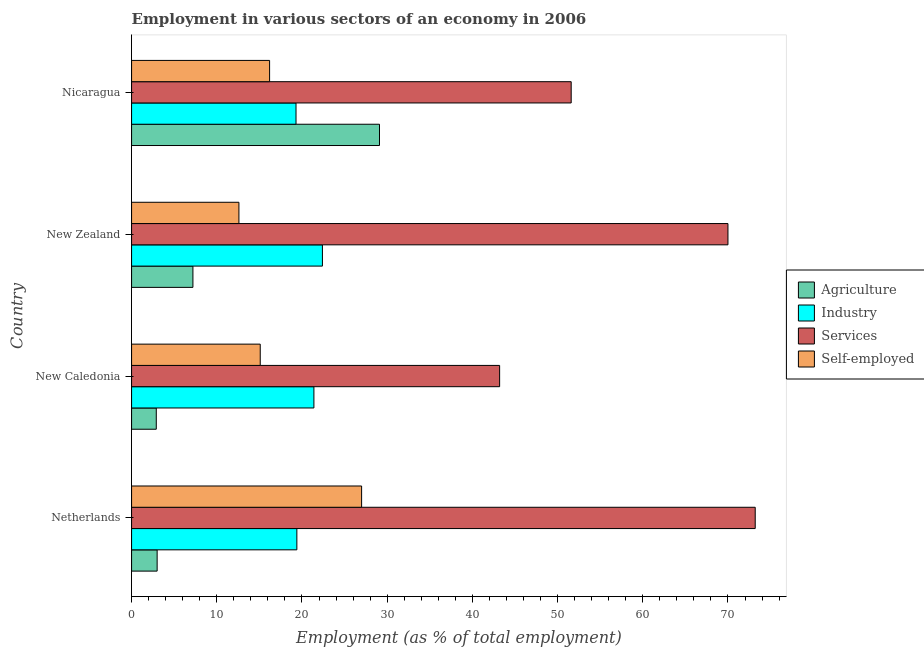Are the number of bars per tick equal to the number of legend labels?
Offer a very short reply. Yes. How many bars are there on the 2nd tick from the bottom?
Your answer should be compact. 4. What is the label of the 1st group of bars from the top?
Keep it short and to the point. Nicaragua. What is the percentage of workers in industry in Netherlands?
Your answer should be compact. 19.4. Across all countries, what is the maximum percentage of workers in agriculture?
Provide a succinct answer. 29.1. Across all countries, what is the minimum percentage of workers in services?
Provide a succinct answer. 43.2. In which country was the percentage of workers in industry maximum?
Keep it short and to the point. New Zealand. In which country was the percentage of workers in services minimum?
Keep it short and to the point. New Caledonia. What is the total percentage of workers in industry in the graph?
Offer a very short reply. 82.5. What is the difference between the percentage of workers in industry in Netherlands and that in New Caledonia?
Give a very brief answer. -2. What is the difference between the percentage of workers in agriculture in New Zealand and the percentage of workers in services in Nicaragua?
Provide a short and direct response. -44.4. What is the average percentage of workers in agriculture per country?
Give a very brief answer. 10.55. What is the difference between the percentage of workers in agriculture and percentage of workers in industry in Nicaragua?
Your answer should be very brief. 9.8. What is the ratio of the percentage of workers in agriculture in New Zealand to that in Nicaragua?
Make the answer very short. 0.25. What is the difference between the highest and the second highest percentage of workers in agriculture?
Your answer should be compact. 21.9. What does the 1st bar from the top in New Zealand represents?
Your answer should be compact. Self-employed. What does the 2nd bar from the bottom in New Zealand represents?
Offer a very short reply. Industry. Is it the case that in every country, the sum of the percentage of workers in agriculture and percentage of workers in industry is greater than the percentage of workers in services?
Keep it short and to the point. No. How many bars are there?
Offer a very short reply. 16. Are all the bars in the graph horizontal?
Your answer should be very brief. Yes. Are the values on the major ticks of X-axis written in scientific E-notation?
Offer a terse response. No. Where does the legend appear in the graph?
Your response must be concise. Center right. How many legend labels are there?
Keep it short and to the point. 4. How are the legend labels stacked?
Provide a succinct answer. Vertical. What is the title of the graph?
Offer a terse response. Employment in various sectors of an economy in 2006. Does "UNHCR" appear as one of the legend labels in the graph?
Keep it short and to the point. No. What is the label or title of the X-axis?
Your response must be concise. Employment (as % of total employment). What is the label or title of the Y-axis?
Your answer should be compact. Country. What is the Employment (as % of total employment) of Agriculture in Netherlands?
Provide a succinct answer. 3. What is the Employment (as % of total employment) of Industry in Netherlands?
Provide a short and direct response. 19.4. What is the Employment (as % of total employment) of Services in Netherlands?
Your answer should be compact. 73.2. What is the Employment (as % of total employment) in Agriculture in New Caledonia?
Keep it short and to the point. 2.9. What is the Employment (as % of total employment) of Industry in New Caledonia?
Your answer should be compact. 21.4. What is the Employment (as % of total employment) of Services in New Caledonia?
Your response must be concise. 43.2. What is the Employment (as % of total employment) in Self-employed in New Caledonia?
Your answer should be very brief. 15.1. What is the Employment (as % of total employment) of Agriculture in New Zealand?
Provide a succinct answer. 7.2. What is the Employment (as % of total employment) of Industry in New Zealand?
Ensure brevity in your answer.  22.4. What is the Employment (as % of total employment) of Services in New Zealand?
Your answer should be very brief. 70. What is the Employment (as % of total employment) of Self-employed in New Zealand?
Give a very brief answer. 12.6. What is the Employment (as % of total employment) of Agriculture in Nicaragua?
Your answer should be very brief. 29.1. What is the Employment (as % of total employment) in Industry in Nicaragua?
Give a very brief answer. 19.3. What is the Employment (as % of total employment) of Services in Nicaragua?
Provide a short and direct response. 51.6. What is the Employment (as % of total employment) of Self-employed in Nicaragua?
Provide a short and direct response. 16.2. Across all countries, what is the maximum Employment (as % of total employment) of Agriculture?
Your answer should be very brief. 29.1. Across all countries, what is the maximum Employment (as % of total employment) in Industry?
Give a very brief answer. 22.4. Across all countries, what is the maximum Employment (as % of total employment) in Services?
Offer a very short reply. 73.2. Across all countries, what is the maximum Employment (as % of total employment) of Self-employed?
Your answer should be very brief. 27. Across all countries, what is the minimum Employment (as % of total employment) in Agriculture?
Offer a very short reply. 2.9. Across all countries, what is the minimum Employment (as % of total employment) in Industry?
Ensure brevity in your answer.  19.3. Across all countries, what is the minimum Employment (as % of total employment) of Services?
Make the answer very short. 43.2. Across all countries, what is the minimum Employment (as % of total employment) in Self-employed?
Make the answer very short. 12.6. What is the total Employment (as % of total employment) in Agriculture in the graph?
Offer a very short reply. 42.2. What is the total Employment (as % of total employment) of Industry in the graph?
Your answer should be compact. 82.5. What is the total Employment (as % of total employment) in Services in the graph?
Make the answer very short. 238. What is the total Employment (as % of total employment) in Self-employed in the graph?
Your answer should be compact. 70.9. What is the difference between the Employment (as % of total employment) in Agriculture in Netherlands and that in New Caledonia?
Provide a succinct answer. 0.1. What is the difference between the Employment (as % of total employment) in Industry in Netherlands and that in New Caledonia?
Offer a very short reply. -2. What is the difference between the Employment (as % of total employment) of Self-employed in Netherlands and that in New Caledonia?
Ensure brevity in your answer.  11.9. What is the difference between the Employment (as % of total employment) of Agriculture in Netherlands and that in New Zealand?
Your response must be concise. -4.2. What is the difference between the Employment (as % of total employment) in Industry in Netherlands and that in New Zealand?
Offer a terse response. -3. What is the difference between the Employment (as % of total employment) in Self-employed in Netherlands and that in New Zealand?
Provide a succinct answer. 14.4. What is the difference between the Employment (as % of total employment) of Agriculture in Netherlands and that in Nicaragua?
Ensure brevity in your answer.  -26.1. What is the difference between the Employment (as % of total employment) in Industry in Netherlands and that in Nicaragua?
Give a very brief answer. 0.1. What is the difference between the Employment (as % of total employment) in Services in Netherlands and that in Nicaragua?
Provide a short and direct response. 21.6. What is the difference between the Employment (as % of total employment) of Self-employed in Netherlands and that in Nicaragua?
Make the answer very short. 10.8. What is the difference between the Employment (as % of total employment) in Industry in New Caledonia and that in New Zealand?
Keep it short and to the point. -1. What is the difference between the Employment (as % of total employment) of Services in New Caledonia and that in New Zealand?
Make the answer very short. -26.8. What is the difference between the Employment (as % of total employment) of Agriculture in New Caledonia and that in Nicaragua?
Offer a terse response. -26.2. What is the difference between the Employment (as % of total employment) of Agriculture in New Zealand and that in Nicaragua?
Your response must be concise. -21.9. What is the difference between the Employment (as % of total employment) in Industry in New Zealand and that in Nicaragua?
Provide a short and direct response. 3.1. What is the difference between the Employment (as % of total employment) in Services in New Zealand and that in Nicaragua?
Provide a short and direct response. 18.4. What is the difference between the Employment (as % of total employment) of Agriculture in Netherlands and the Employment (as % of total employment) of Industry in New Caledonia?
Give a very brief answer. -18.4. What is the difference between the Employment (as % of total employment) of Agriculture in Netherlands and the Employment (as % of total employment) of Services in New Caledonia?
Offer a terse response. -40.2. What is the difference between the Employment (as % of total employment) of Industry in Netherlands and the Employment (as % of total employment) of Services in New Caledonia?
Your response must be concise. -23.8. What is the difference between the Employment (as % of total employment) in Services in Netherlands and the Employment (as % of total employment) in Self-employed in New Caledonia?
Your response must be concise. 58.1. What is the difference between the Employment (as % of total employment) of Agriculture in Netherlands and the Employment (as % of total employment) of Industry in New Zealand?
Offer a very short reply. -19.4. What is the difference between the Employment (as % of total employment) in Agriculture in Netherlands and the Employment (as % of total employment) in Services in New Zealand?
Ensure brevity in your answer.  -67. What is the difference between the Employment (as % of total employment) of Agriculture in Netherlands and the Employment (as % of total employment) of Self-employed in New Zealand?
Offer a very short reply. -9.6. What is the difference between the Employment (as % of total employment) of Industry in Netherlands and the Employment (as % of total employment) of Services in New Zealand?
Ensure brevity in your answer.  -50.6. What is the difference between the Employment (as % of total employment) in Services in Netherlands and the Employment (as % of total employment) in Self-employed in New Zealand?
Offer a very short reply. 60.6. What is the difference between the Employment (as % of total employment) in Agriculture in Netherlands and the Employment (as % of total employment) in Industry in Nicaragua?
Offer a terse response. -16.3. What is the difference between the Employment (as % of total employment) of Agriculture in Netherlands and the Employment (as % of total employment) of Services in Nicaragua?
Your response must be concise. -48.6. What is the difference between the Employment (as % of total employment) in Agriculture in Netherlands and the Employment (as % of total employment) in Self-employed in Nicaragua?
Provide a succinct answer. -13.2. What is the difference between the Employment (as % of total employment) of Industry in Netherlands and the Employment (as % of total employment) of Services in Nicaragua?
Provide a short and direct response. -32.2. What is the difference between the Employment (as % of total employment) of Industry in Netherlands and the Employment (as % of total employment) of Self-employed in Nicaragua?
Offer a terse response. 3.2. What is the difference between the Employment (as % of total employment) of Services in Netherlands and the Employment (as % of total employment) of Self-employed in Nicaragua?
Make the answer very short. 57. What is the difference between the Employment (as % of total employment) in Agriculture in New Caledonia and the Employment (as % of total employment) in Industry in New Zealand?
Keep it short and to the point. -19.5. What is the difference between the Employment (as % of total employment) of Agriculture in New Caledonia and the Employment (as % of total employment) of Services in New Zealand?
Ensure brevity in your answer.  -67.1. What is the difference between the Employment (as % of total employment) in Industry in New Caledonia and the Employment (as % of total employment) in Services in New Zealand?
Provide a succinct answer. -48.6. What is the difference between the Employment (as % of total employment) of Services in New Caledonia and the Employment (as % of total employment) of Self-employed in New Zealand?
Make the answer very short. 30.6. What is the difference between the Employment (as % of total employment) of Agriculture in New Caledonia and the Employment (as % of total employment) of Industry in Nicaragua?
Offer a terse response. -16.4. What is the difference between the Employment (as % of total employment) of Agriculture in New Caledonia and the Employment (as % of total employment) of Services in Nicaragua?
Give a very brief answer. -48.7. What is the difference between the Employment (as % of total employment) in Agriculture in New Caledonia and the Employment (as % of total employment) in Self-employed in Nicaragua?
Offer a terse response. -13.3. What is the difference between the Employment (as % of total employment) of Industry in New Caledonia and the Employment (as % of total employment) of Services in Nicaragua?
Ensure brevity in your answer.  -30.2. What is the difference between the Employment (as % of total employment) in Agriculture in New Zealand and the Employment (as % of total employment) in Services in Nicaragua?
Ensure brevity in your answer.  -44.4. What is the difference between the Employment (as % of total employment) in Agriculture in New Zealand and the Employment (as % of total employment) in Self-employed in Nicaragua?
Your response must be concise. -9. What is the difference between the Employment (as % of total employment) of Industry in New Zealand and the Employment (as % of total employment) of Services in Nicaragua?
Your answer should be compact. -29.2. What is the difference between the Employment (as % of total employment) of Industry in New Zealand and the Employment (as % of total employment) of Self-employed in Nicaragua?
Your answer should be very brief. 6.2. What is the difference between the Employment (as % of total employment) of Services in New Zealand and the Employment (as % of total employment) of Self-employed in Nicaragua?
Offer a very short reply. 53.8. What is the average Employment (as % of total employment) of Agriculture per country?
Offer a terse response. 10.55. What is the average Employment (as % of total employment) in Industry per country?
Give a very brief answer. 20.62. What is the average Employment (as % of total employment) in Services per country?
Keep it short and to the point. 59.5. What is the average Employment (as % of total employment) in Self-employed per country?
Your answer should be very brief. 17.73. What is the difference between the Employment (as % of total employment) in Agriculture and Employment (as % of total employment) in Industry in Netherlands?
Make the answer very short. -16.4. What is the difference between the Employment (as % of total employment) of Agriculture and Employment (as % of total employment) of Services in Netherlands?
Provide a short and direct response. -70.2. What is the difference between the Employment (as % of total employment) in Industry and Employment (as % of total employment) in Services in Netherlands?
Give a very brief answer. -53.8. What is the difference between the Employment (as % of total employment) in Services and Employment (as % of total employment) in Self-employed in Netherlands?
Your answer should be compact. 46.2. What is the difference between the Employment (as % of total employment) of Agriculture and Employment (as % of total employment) of Industry in New Caledonia?
Provide a succinct answer. -18.5. What is the difference between the Employment (as % of total employment) of Agriculture and Employment (as % of total employment) of Services in New Caledonia?
Provide a succinct answer. -40.3. What is the difference between the Employment (as % of total employment) in Agriculture and Employment (as % of total employment) in Self-employed in New Caledonia?
Provide a short and direct response. -12.2. What is the difference between the Employment (as % of total employment) of Industry and Employment (as % of total employment) of Services in New Caledonia?
Provide a short and direct response. -21.8. What is the difference between the Employment (as % of total employment) in Industry and Employment (as % of total employment) in Self-employed in New Caledonia?
Make the answer very short. 6.3. What is the difference between the Employment (as % of total employment) of Services and Employment (as % of total employment) of Self-employed in New Caledonia?
Your answer should be very brief. 28.1. What is the difference between the Employment (as % of total employment) in Agriculture and Employment (as % of total employment) in Industry in New Zealand?
Ensure brevity in your answer.  -15.2. What is the difference between the Employment (as % of total employment) of Agriculture and Employment (as % of total employment) of Services in New Zealand?
Keep it short and to the point. -62.8. What is the difference between the Employment (as % of total employment) of Industry and Employment (as % of total employment) of Services in New Zealand?
Offer a very short reply. -47.6. What is the difference between the Employment (as % of total employment) in Industry and Employment (as % of total employment) in Self-employed in New Zealand?
Provide a succinct answer. 9.8. What is the difference between the Employment (as % of total employment) of Services and Employment (as % of total employment) of Self-employed in New Zealand?
Your answer should be compact. 57.4. What is the difference between the Employment (as % of total employment) in Agriculture and Employment (as % of total employment) in Industry in Nicaragua?
Your answer should be very brief. 9.8. What is the difference between the Employment (as % of total employment) of Agriculture and Employment (as % of total employment) of Services in Nicaragua?
Your response must be concise. -22.5. What is the difference between the Employment (as % of total employment) in Agriculture and Employment (as % of total employment) in Self-employed in Nicaragua?
Ensure brevity in your answer.  12.9. What is the difference between the Employment (as % of total employment) of Industry and Employment (as % of total employment) of Services in Nicaragua?
Your answer should be compact. -32.3. What is the difference between the Employment (as % of total employment) in Services and Employment (as % of total employment) in Self-employed in Nicaragua?
Keep it short and to the point. 35.4. What is the ratio of the Employment (as % of total employment) in Agriculture in Netherlands to that in New Caledonia?
Make the answer very short. 1.03. What is the ratio of the Employment (as % of total employment) in Industry in Netherlands to that in New Caledonia?
Provide a short and direct response. 0.91. What is the ratio of the Employment (as % of total employment) in Services in Netherlands to that in New Caledonia?
Provide a short and direct response. 1.69. What is the ratio of the Employment (as % of total employment) of Self-employed in Netherlands to that in New Caledonia?
Your answer should be very brief. 1.79. What is the ratio of the Employment (as % of total employment) of Agriculture in Netherlands to that in New Zealand?
Offer a very short reply. 0.42. What is the ratio of the Employment (as % of total employment) in Industry in Netherlands to that in New Zealand?
Ensure brevity in your answer.  0.87. What is the ratio of the Employment (as % of total employment) of Services in Netherlands to that in New Zealand?
Your answer should be compact. 1.05. What is the ratio of the Employment (as % of total employment) of Self-employed in Netherlands to that in New Zealand?
Offer a terse response. 2.14. What is the ratio of the Employment (as % of total employment) of Agriculture in Netherlands to that in Nicaragua?
Provide a succinct answer. 0.1. What is the ratio of the Employment (as % of total employment) of Services in Netherlands to that in Nicaragua?
Your answer should be very brief. 1.42. What is the ratio of the Employment (as % of total employment) in Agriculture in New Caledonia to that in New Zealand?
Offer a very short reply. 0.4. What is the ratio of the Employment (as % of total employment) in Industry in New Caledonia to that in New Zealand?
Provide a succinct answer. 0.96. What is the ratio of the Employment (as % of total employment) of Services in New Caledonia to that in New Zealand?
Keep it short and to the point. 0.62. What is the ratio of the Employment (as % of total employment) in Self-employed in New Caledonia to that in New Zealand?
Provide a short and direct response. 1.2. What is the ratio of the Employment (as % of total employment) of Agriculture in New Caledonia to that in Nicaragua?
Offer a terse response. 0.1. What is the ratio of the Employment (as % of total employment) of Industry in New Caledonia to that in Nicaragua?
Your answer should be compact. 1.11. What is the ratio of the Employment (as % of total employment) of Services in New Caledonia to that in Nicaragua?
Offer a terse response. 0.84. What is the ratio of the Employment (as % of total employment) of Self-employed in New Caledonia to that in Nicaragua?
Provide a succinct answer. 0.93. What is the ratio of the Employment (as % of total employment) of Agriculture in New Zealand to that in Nicaragua?
Your answer should be compact. 0.25. What is the ratio of the Employment (as % of total employment) in Industry in New Zealand to that in Nicaragua?
Offer a terse response. 1.16. What is the ratio of the Employment (as % of total employment) in Services in New Zealand to that in Nicaragua?
Your answer should be compact. 1.36. What is the difference between the highest and the second highest Employment (as % of total employment) of Agriculture?
Provide a succinct answer. 21.9. What is the difference between the highest and the second highest Employment (as % of total employment) of Industry?
Make the answer very short. 1. What is the difference between the highest and the second highest Employment (as % of total employment) in Services?
Make the answer very short. 3.2. What is the difference between the highest and the second highest Employment (as % of total employment) in Self-employed?
Provide a succinct answer. 10.8. What is the difference between the highest and the lowest Employment (as % of total employment) of Agriculture?
Give a very brief answer. 26.2. What is the difference between the highest and the lowest Employment (as % of total employment) in Industry?
Provide a succinct answer. 3.1. 